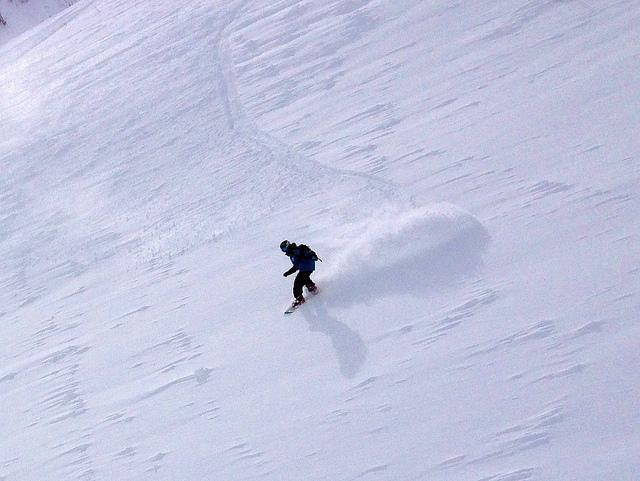How many buses are there going to max north?
Give a very brief answer. 0. 